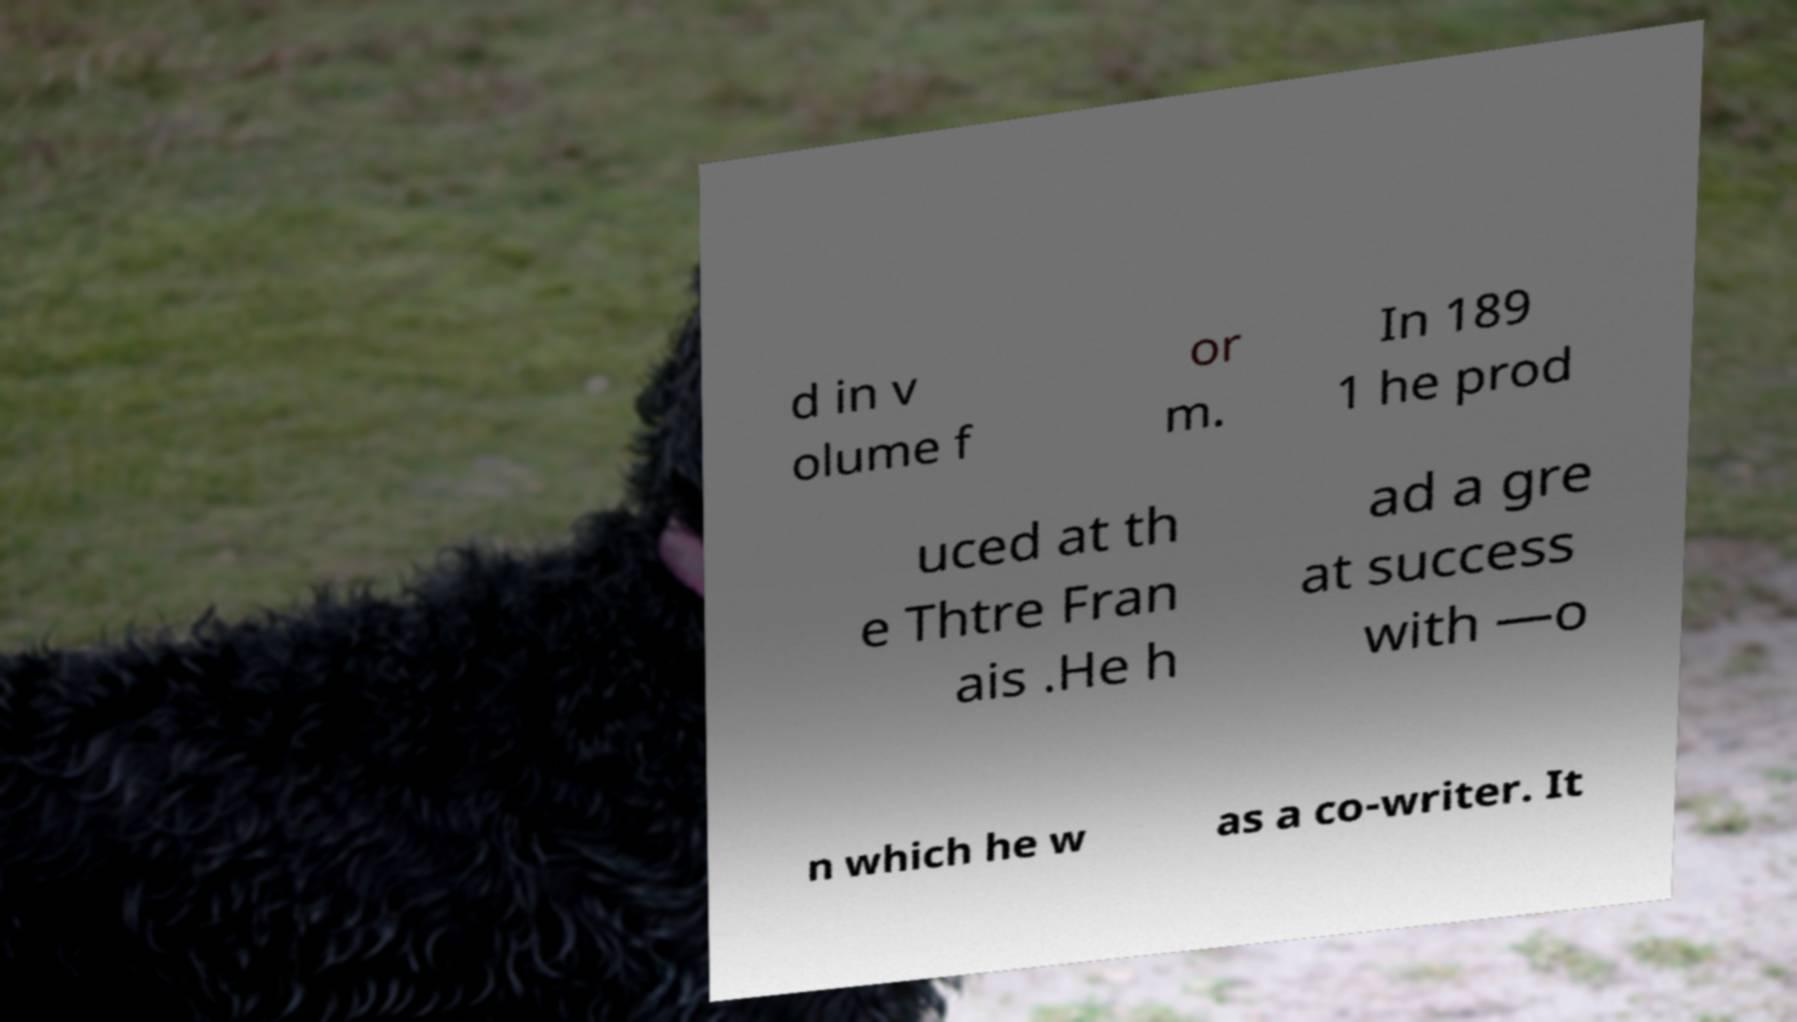I need the written content from this picture converted into text. Can you do that? d in v olume f or m. In 189 1 he prod uced at th e Thtre Fran ais .He h ad a gre at success with —o n which he w as a co-writer. It 